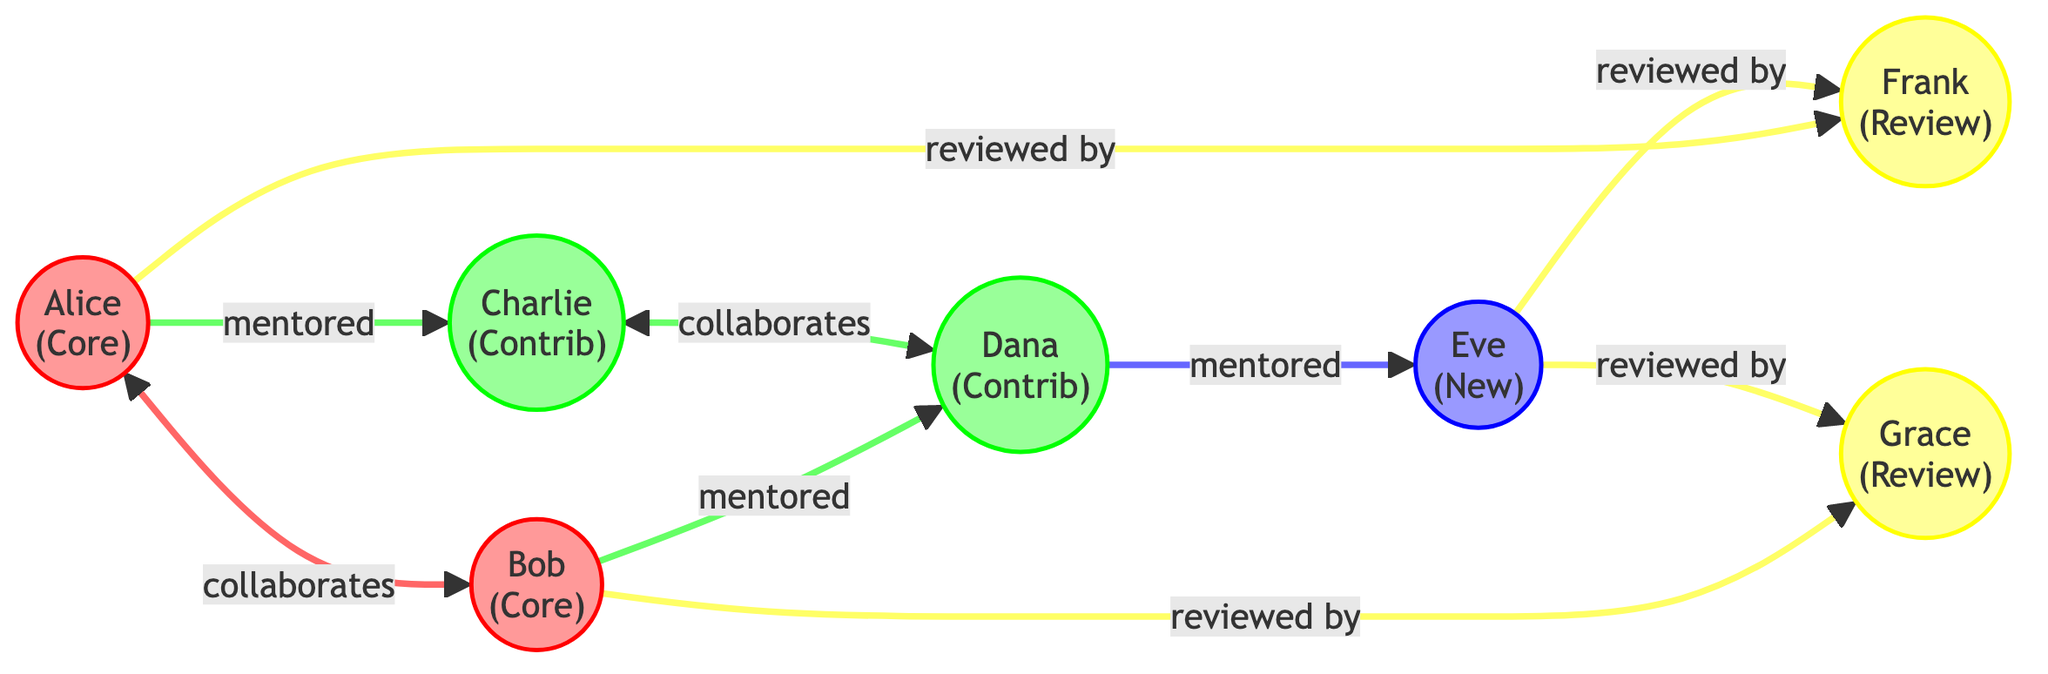What is the role of Alice? The diagram indicates that Alice is labeled as "Core Maintainer" with an associated role.
Answer: Core Maintainer How many nodes are there in total? By counting all the individual nodes represented in the diagram, we find that there are 7 nodes.
Answer: 7 Who does Bob mentor? The diagram shows a directed edge from Bob to Dana, indicating that he mentors her.
Answer: Dana What type of relationship exists between Alice and Charlie? The arrow from Alice to Charlie indicates a "mentored" relationship, which specifies the nature of their interaction.
Answer: mentored How many contributors are there? By examining the nodes, we see that Charlie, Dana, and Eve are labeled as contributors, totaling three contributors.
Answer: 3 Which reviewer reviews Frankie? The diagram presents directed edges from Frank to both Eve and Grace, showing both of them as reviewers of Frankie.
Answer: Frank What is the total number of edges in the diagram? By counting the directed connections between nodes, we can determine that there are 9 edges in total.
Answer: 9 How is the relationship between Charlie and Dana described? There is a bidirectional edge between Charlie and Dana labeled "collaborates with," highlighting their peer relationship.
Answer: collaborates with Who collaborates with Bob? The diagram indicates a direct collaboration between Bob and Alice, showing that they work together closely.
Answer: Alice 